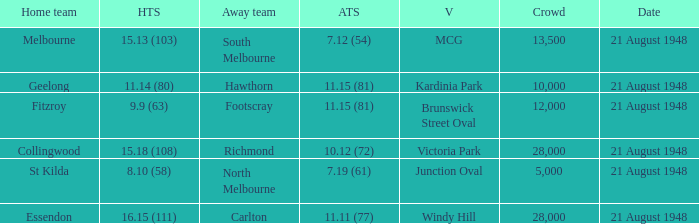When the home team's score was 15.18 (108), what was the minimum number of attendees in the crowd? 28000.0. 